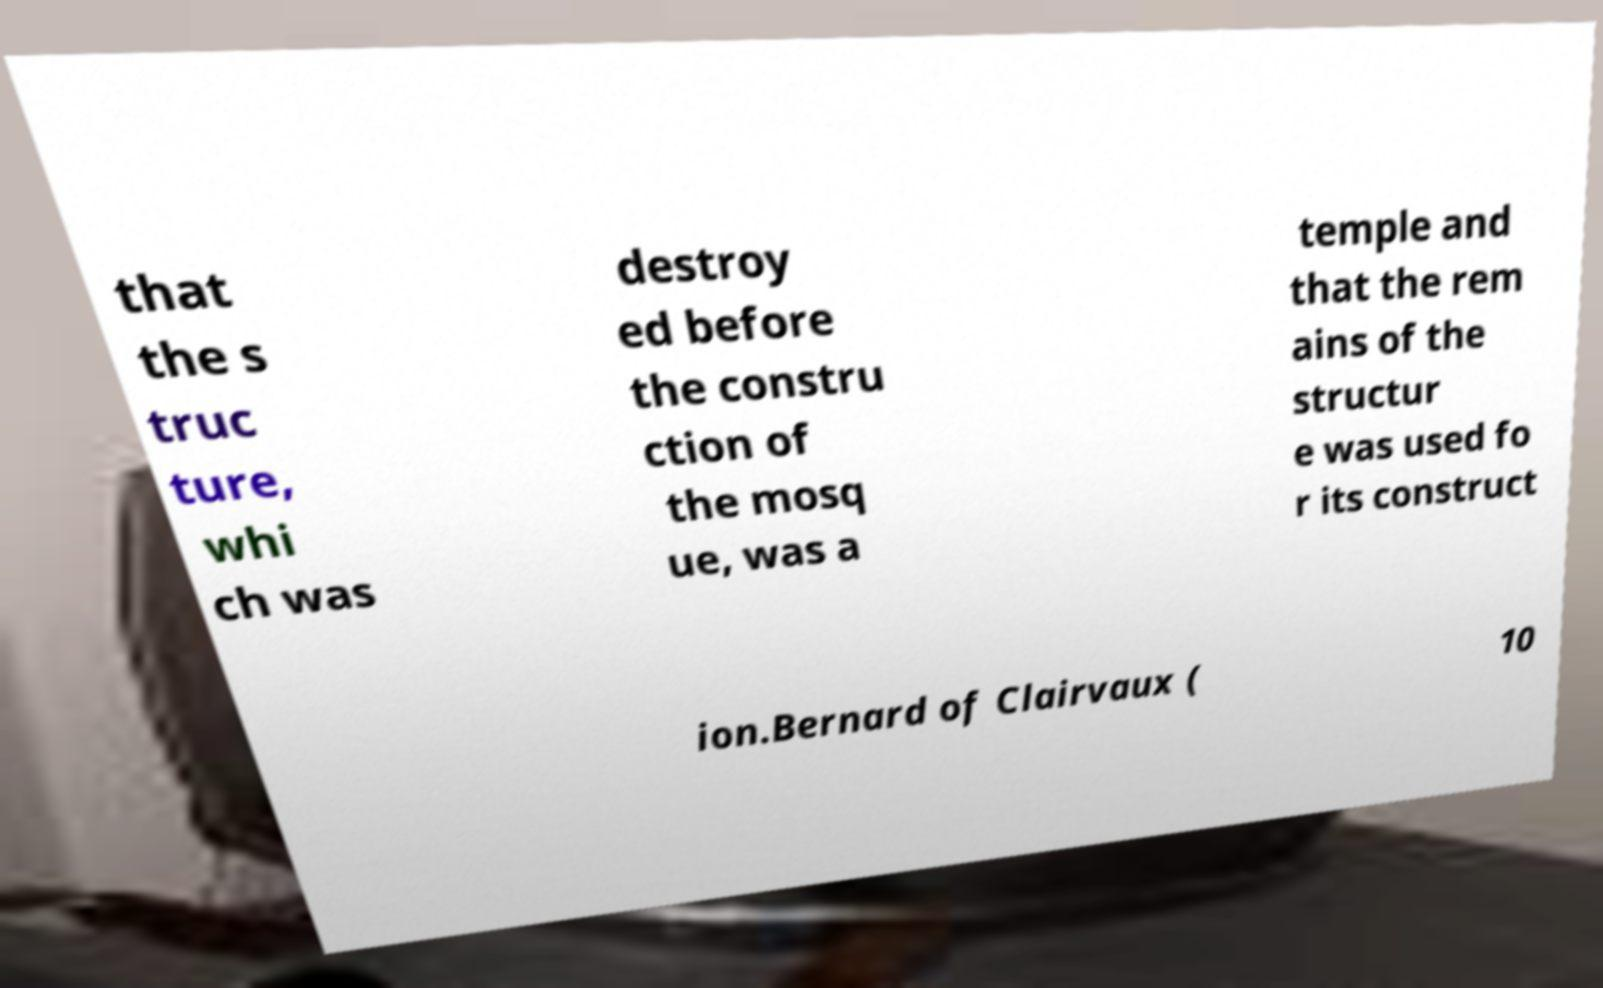Could you assist in decoding the text presented in this image and type it out clearly? that the s truc ture, whi ch was destroy ed before the constru ction of the mosq ue, was a temple and that the rem ains of the structur e was used fo r its construct ion.Bernard of Clairvaux ( 10 